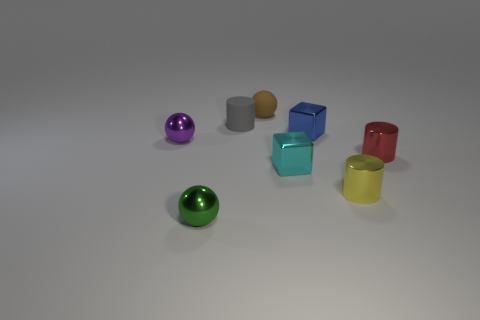Is the blue shiny object the same shape as the red shiny object?
Offer a very short reply. No. What is the color of the cube that is the same size as the blue thing?
Keep it short and to the point. Cyan. Is there a cylinder of the same color as the matte ball?
Provide a succinct answer. No. Are there any tiny purple things?
Your answer should be compact. Yes. Is the material of the tiny block that is in front of the small blue shiny block the same as the gray cylinder?
Offer a very short reply. No. What number of blocks have the same size as the brown ball?
Your answer should be compact. 2. Are there an equal number of small matte spheres that are to the right of the red thing and big yellow shiny objects?
Ensure brevity in your answer.  Yes. What number of things are to the left of the red thing and on the right side of the small purple shiny object?
Make the answer very short. 6. There is a cyan block that is the same material as the purple sphere; what is its size?
Your answer should be very brief. Small. What number of other small objects are the same shape as the yellow metallic thing?
Your response must be concise. 2. 